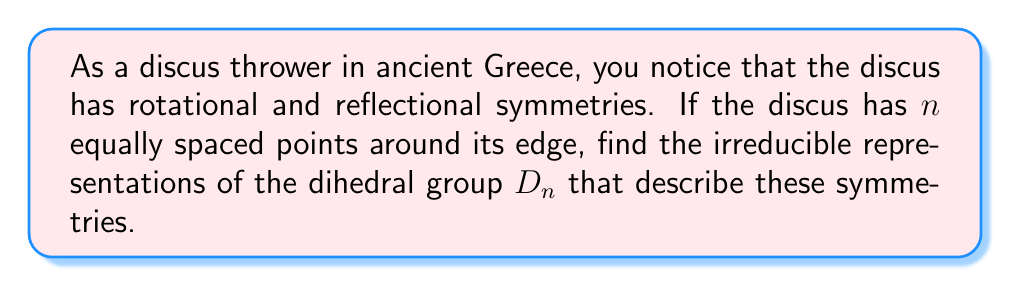Show me your answer to this math problem. Let's approach this step-by-step:

1) The dihedral group $D_n$ has $2n$ elements: $n$ rotations and $n$ reflections.

2) For $D_n$, we have the following irreducible representations:

   a) Two 1-dimensional representations:
      - The trivial representation: $\rho_1(r) = \rho_1(s) = 1$
      - The sign representation: $\rho_2(r) = 1, \rho_2(s) = -1$
      
      where $r$ is a rotation and $s$ is a reflection.

   b) $\lfloor \frac{n-1}{2} \rfloor$ 2-dimensional representations:
      For $k = 1, 2, ..., \lfloor \frac{n-1}{2} \rfloor$,
      
      $$\rho_k(r) = \begin{pmatrix} 
      \cos(\frac{2\pi k}{n}) & -\sin(\frac{2\pi k}{n}) \\
      \sin(\frac{2\pi k}{n}) & \cos(\frac{2\pi k}{n})
      \end{pmatrix}$$
      
      $$\rho_k(s) = \begin{pmatrix}
      1 & 0 \\
      0 & -1
      \end{pmatrix}$$

3) If $n$ is odd, these are all the irreducible representations.

4) If $n$ is even, there are two additional 1-dimensional representations:
   - $\rho_3(r) = -1, \rho_3(s) = 1$
   - $\rho_4(r) = -1, \rho_4(s) = -1$

5) We can verify that the sum of squares of dimensions equals the order of the group:
   For odd $n$: $1^2 + 1^2 + 2^2 \cdot \frac{n-1}{2} = 2n$
   For even $n$: $1^2 + 1^2 + 1^2 + 1^2 + 2^2 \cdot \frac{n-2}{2} = 2n$

These representations describe how the discus transforms under rotations and reflections, connecting the ancient sport to modern algebra.
Answer: Two 1D representations, $\lfloor \frac{n-1}{2} \rfloor$ 2D representations, and if $n$ is even, two additional 1D representations. 